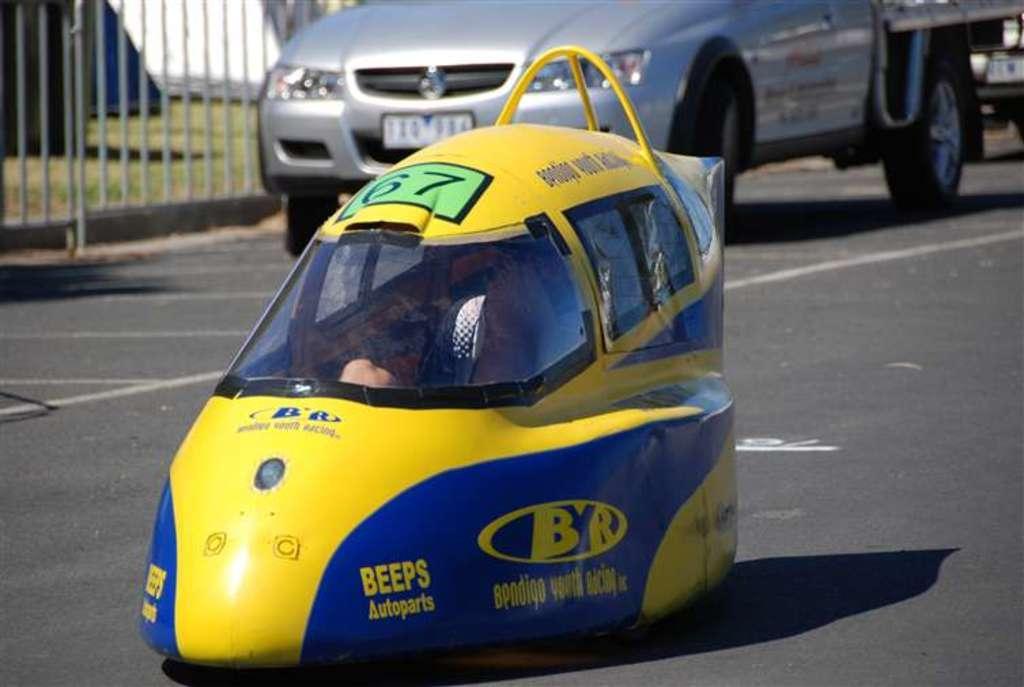Can you describe this image briefly? In this image we can see a car, it is in yellow color, at back here is the car travelling on the road, here is the grass. 